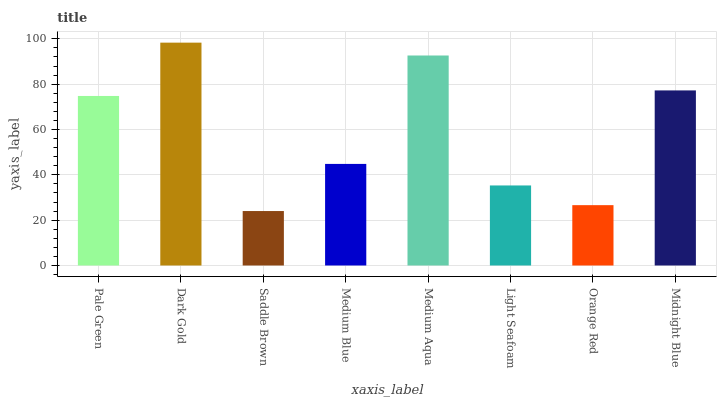Is Saddle Brown the minimum?
Answer yes or no. Yes. Is Dark Gold the maximum?
Answer yes or no. Yes. Is Dark Gold the minimum?
Answer yes or no. No. Is Saddle Brown the maximum?
Answer yes or no. No. Is Dark Gold greater than Saddle Brown?
Answer yes or no. Yes. Is Saddle Brown less than Dark Gold?
Answer yes or no. Yes. Is Saddle Brown greater than Dark Gold?
Answer yes or no. No. Is Dark Gold less than Saddle Brown?
Answer yes or no. No. Is Pale Green the high median?
Answer yes or no. Yes. Is Medium Blue the low median?
Answer yes or no. Yes. Is Medium Blue the high median?
Answer yes or no. No. Is Orange Red the low median?
Answer yes or no. No. 